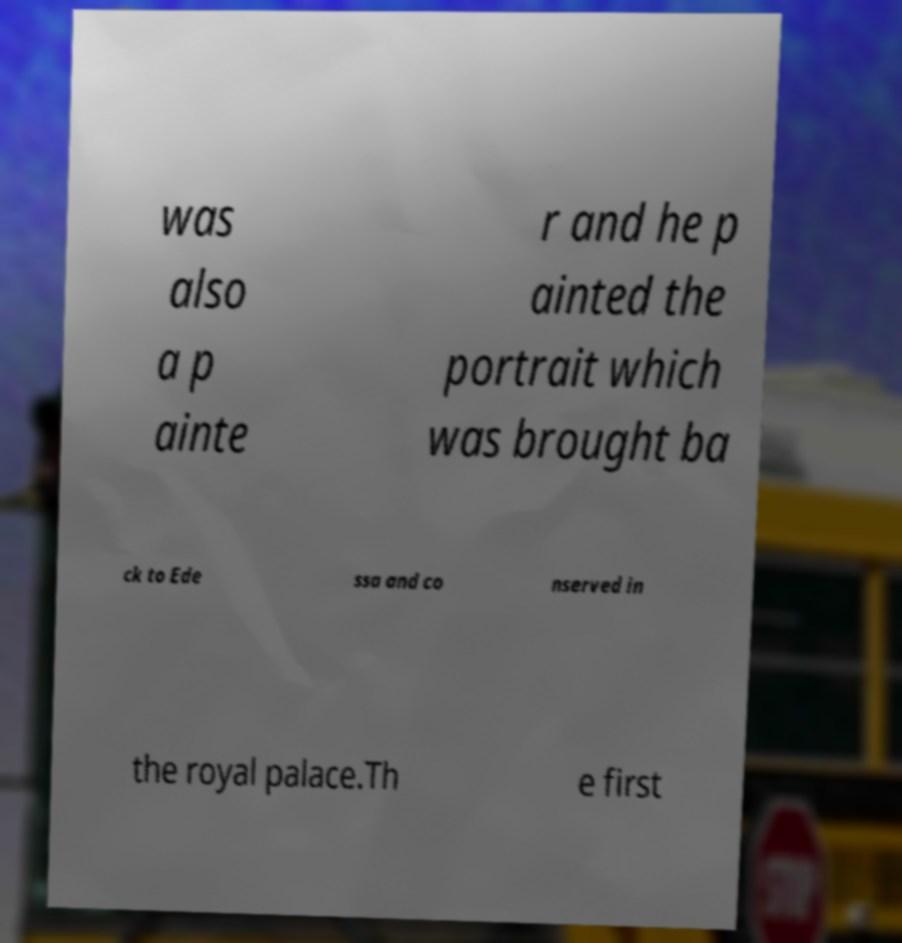Could you assist in decoding the text presented in this image and type it out clearly? was also a p ainte r and he p ainted the portrait which was brought ba ck to Ede ssa and co nserved in the royal palace.Th e first 